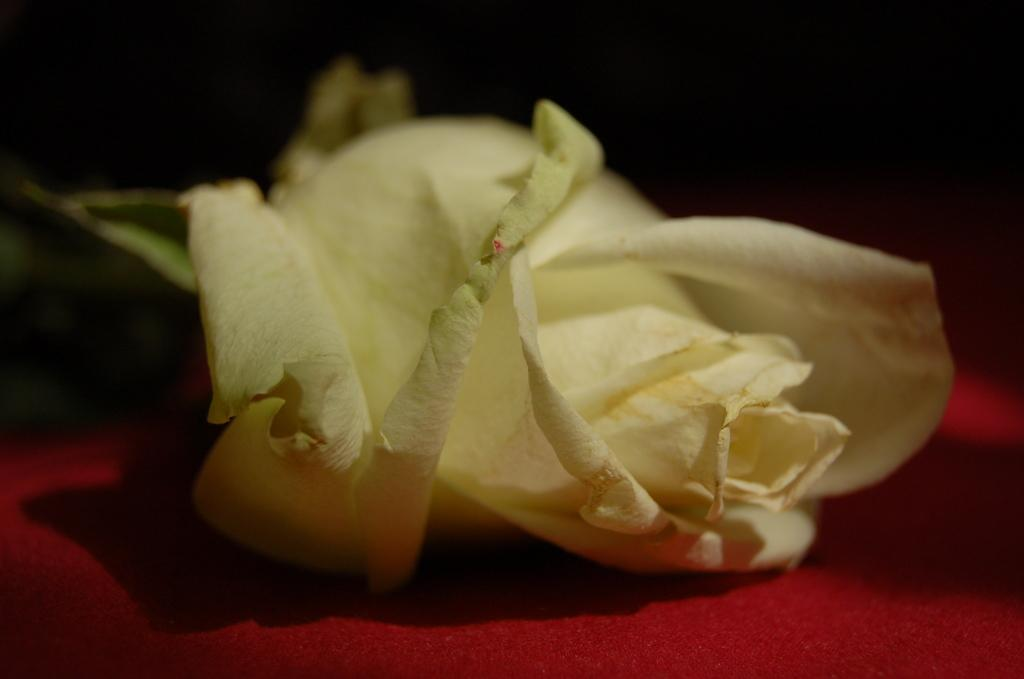What type of flower is in the image? There is a rose in the image. What is the rose placed on? The rose is on a red carpet. What type of fork is used to hold the rose in the image? There is no fork present in the image; the rose is placed on a red carpet. 